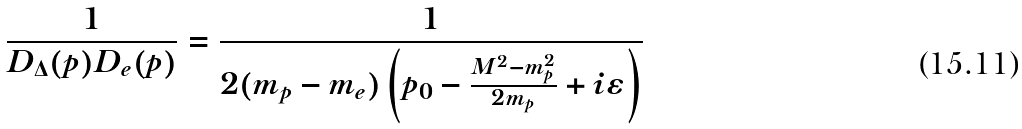Convert formula to latex. <formula><loc_0><loc_0><loc_500><loc_500>\frac { 1 } { D _ { \Delta } ( p ) D _ { e } ( p ) } = \frac { 1 } { 2 ( m _ { p } - m _ { e } ) \left ( p _ { 0 } - \frac { M ^ { 2 } - m _ { p } ^ { 2 } } { 2 m _ { p } } + i \varepsilon \right ) }</formula> 